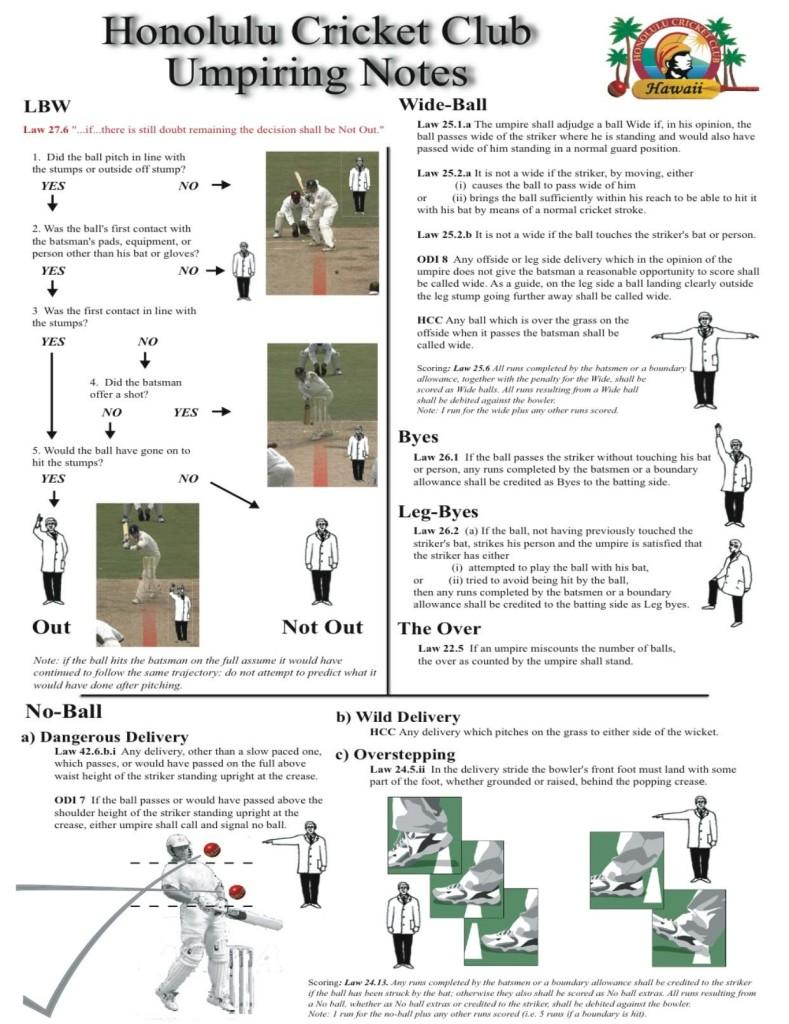Specify some key components in this picture. A ball is called a no-ball in three different ways. A ball is considered a no-ball when it is deemed dangerous, wild, or when the bowler oversteps. 